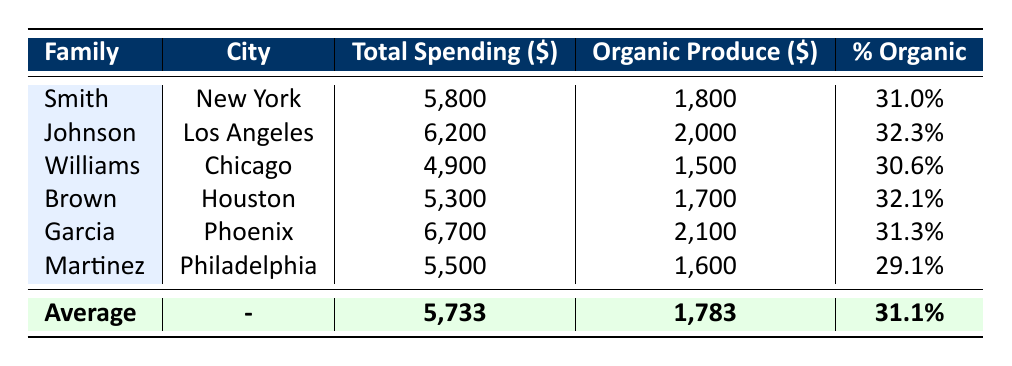What is the total spending of the Garcia family? The table shows the total spending of each family. For the Garcia family, the value listed under the total spending column is 6700.
Answer: 6700 Which family spent the least on organic produce? By comparing the organic produce spending values across all families listed in the table, the Williams family has the lowest value of 1500.
Answer: Williams How much did the Johnson family spend on groceries compared to the average total spending? The Johnson family's total spending is 6200, and the average total spending for all families is 5733. To find the difference, we calculate 6200 - 5733 = 467, indicating Johnson spent more than the average.
Answer: 467 Is it true that the Smith family spent more on organic produce than the Martinez family? Looking at the table, the Smith family's organic produce spending is 1800, while the Martinez family's is 1600. Since 1800 is greater than 1600, the statement is true.
Answer: True What percentage of the Brown family's spending was on organic produce? The Brown family's total spending is 5300 and the organic produce spending is 1700. To find the percentage, we calculate (1700 / 5300) * 100 = 32.1%, which matches the value in the table.
Answer: 32.1% What is the average percentage of spending on organic produce across all families? From the table, we see percentages for each family: 31.0, 32.3, 30.6, 32.1, 31.3, and 29.1. We sum these values (31.0 + 32.3 + 30.6 + 32.1 + 31.3 + 29.1 = 184.4) and divide by the number of families (6) to find the average: 184.4 / 6 = 30.73, which is rounded to 31.1%.
Answer: 31.1% Which city has the highest grocery spending, and how much was spent? By reviewing the total spending for each family, the Garcia family from Phoenix has the highest spending at 6700.
Answer: Phoenix, 6700 How many families surveyed spent more than the average organic produce spending? The average organic produce spending listed is 1783. We compare each family's organic produce spending: Johnson (2000), Garcia (2100), Brown (1700), Smith (1800), Martinez (1600), and Williams (1500). Only Johnson and Garcia spent more than 1783, resulting in 2 families.
Answer: 2 How much more did the Los Angeles family spend compared to the Chicago family? The Johnson family from Los Angeles spent 6200, while the Williams family from Chicago spent 4900. The difference is 6200 - 4900 = 1300.
Answer: 1300 